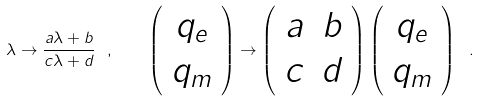Convert formula to latex. <formula><loc_0><loc_0><loc_500><loc_500>\lambda \rightarrow \frac { a \lambda + b } { c \lambda + d } \ , \quad \left ( \begin{array} { c } q _ { e } \\ q _ { m } \end{array} \right ) \rightarrow \left ( \begin{array} { c c } a & b \\ c & d \end{array} \right ) \left ( \begin{array} { c } q _ { e } \\ q _ { m } \end{array} \right ) \ .</formula> 